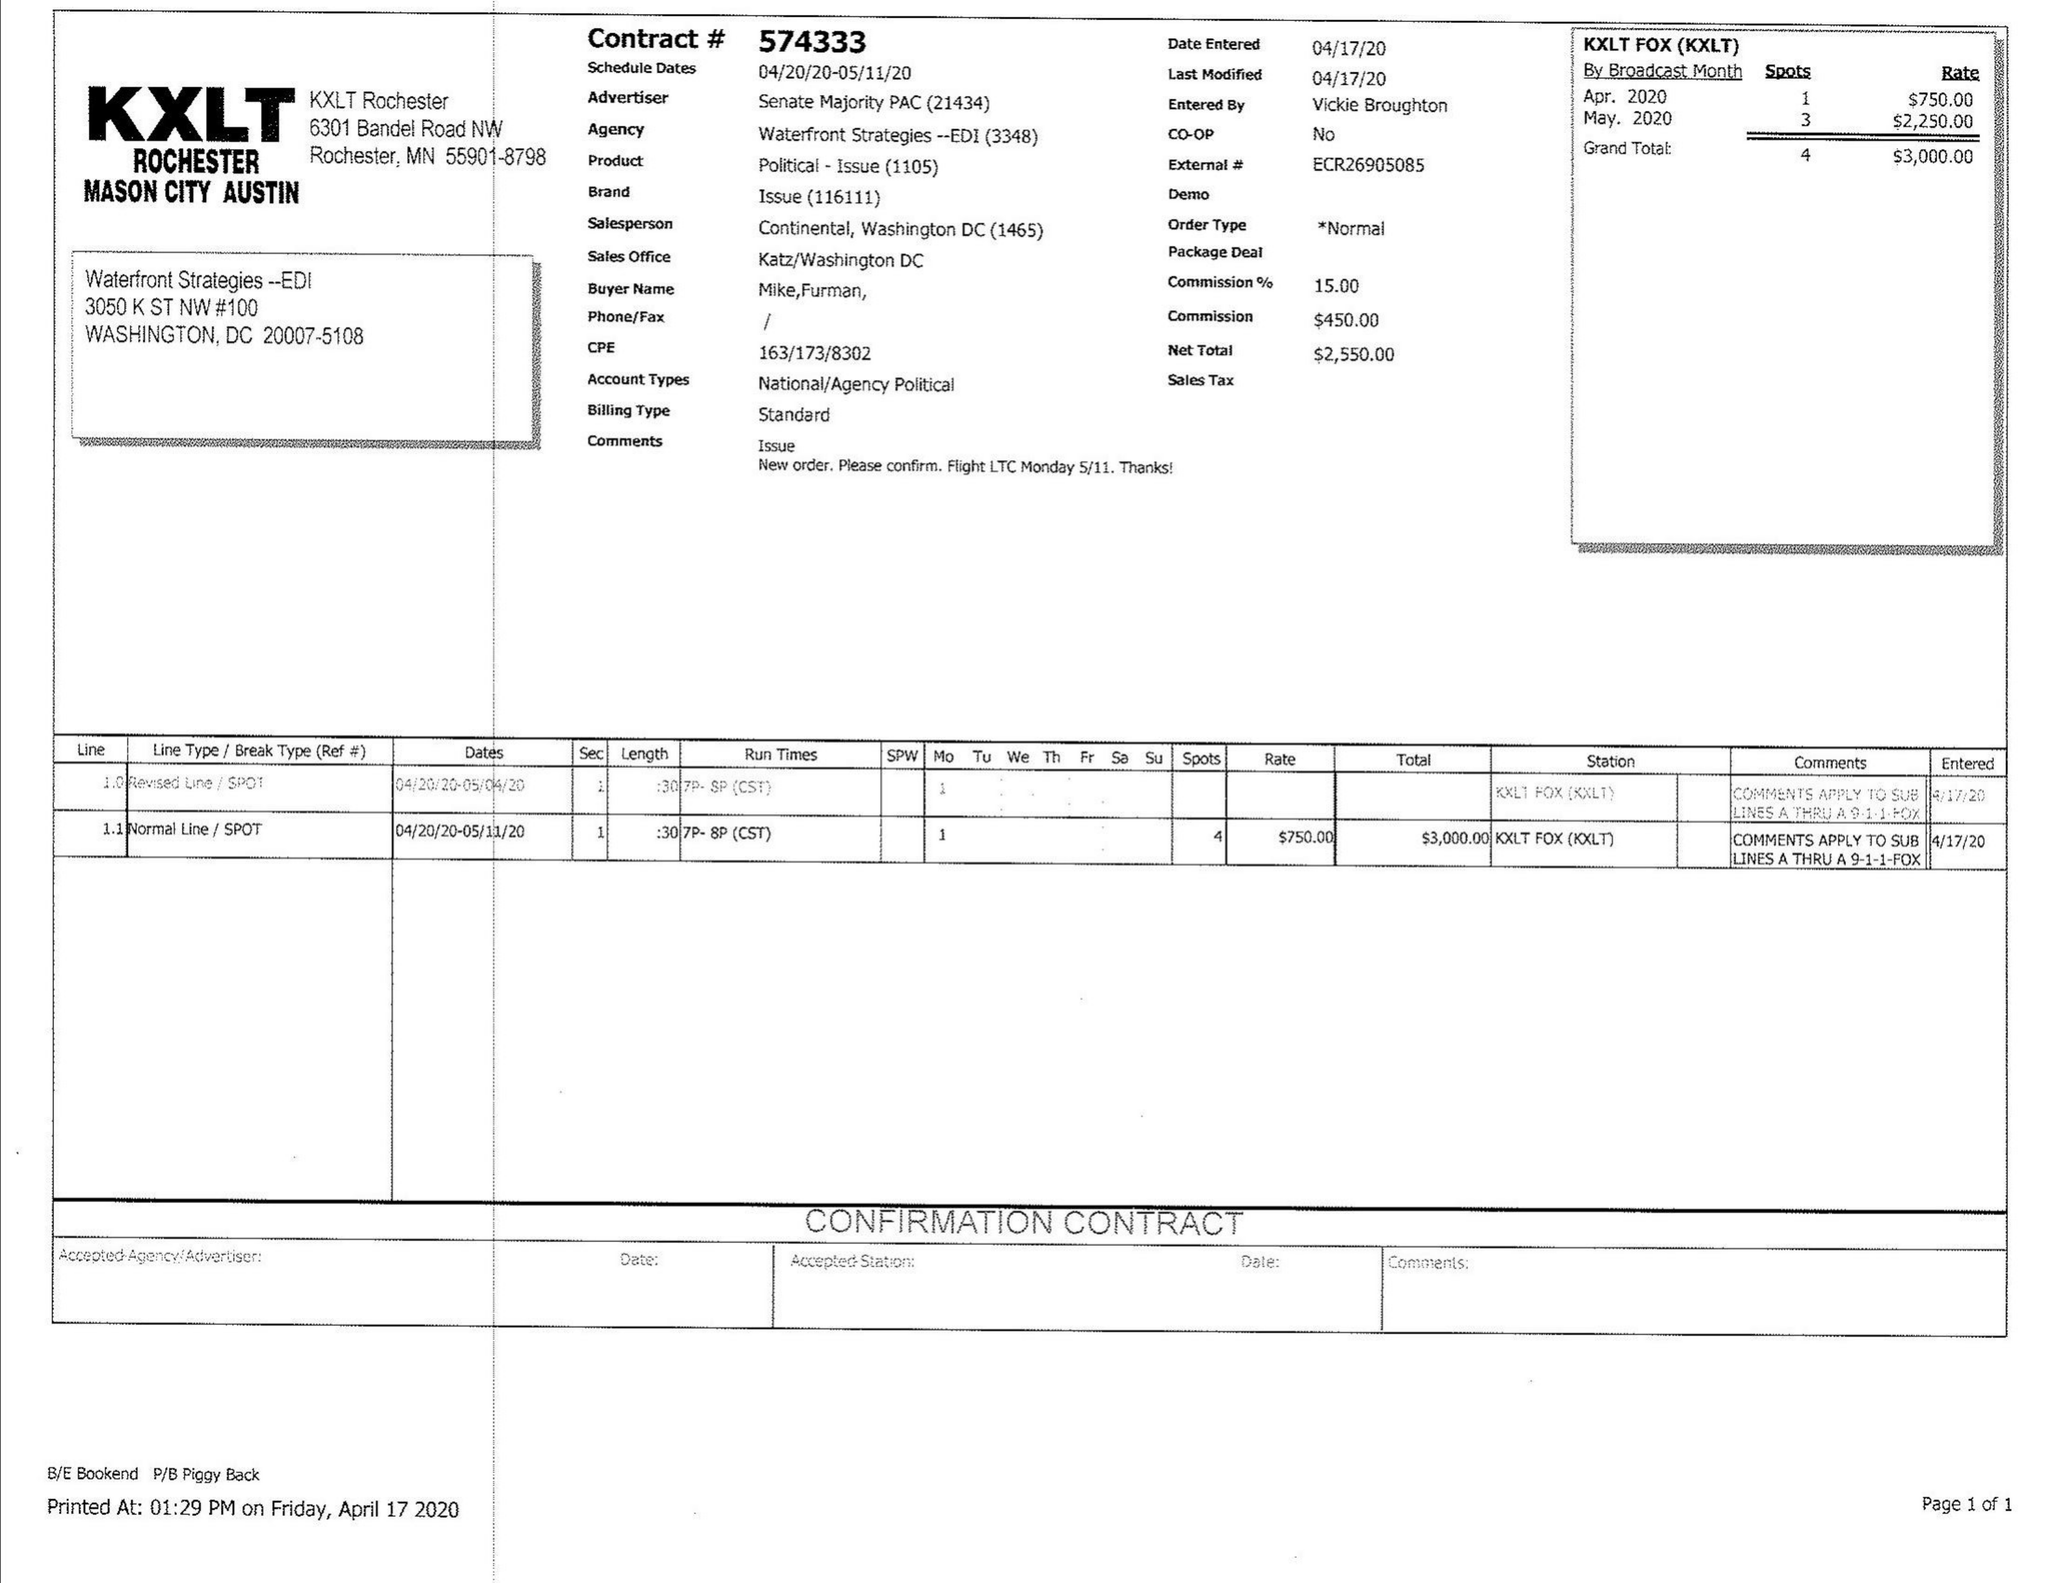What is the value for the flight_to?
Answer the question using a single word or phrase. 05/11/20 